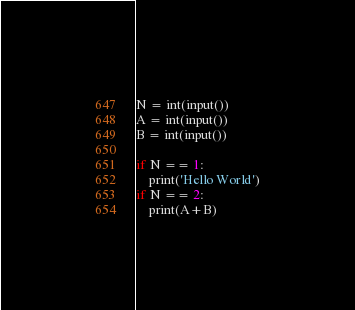Convert code to text. <code><loc_0><loc_0><loc_500><loc_500><_Python_>N = int(input())
A = int(input())
B = int(input())

if N == 1:
    print('Hello World')
if N == 2:
    print(A+B)</code> 